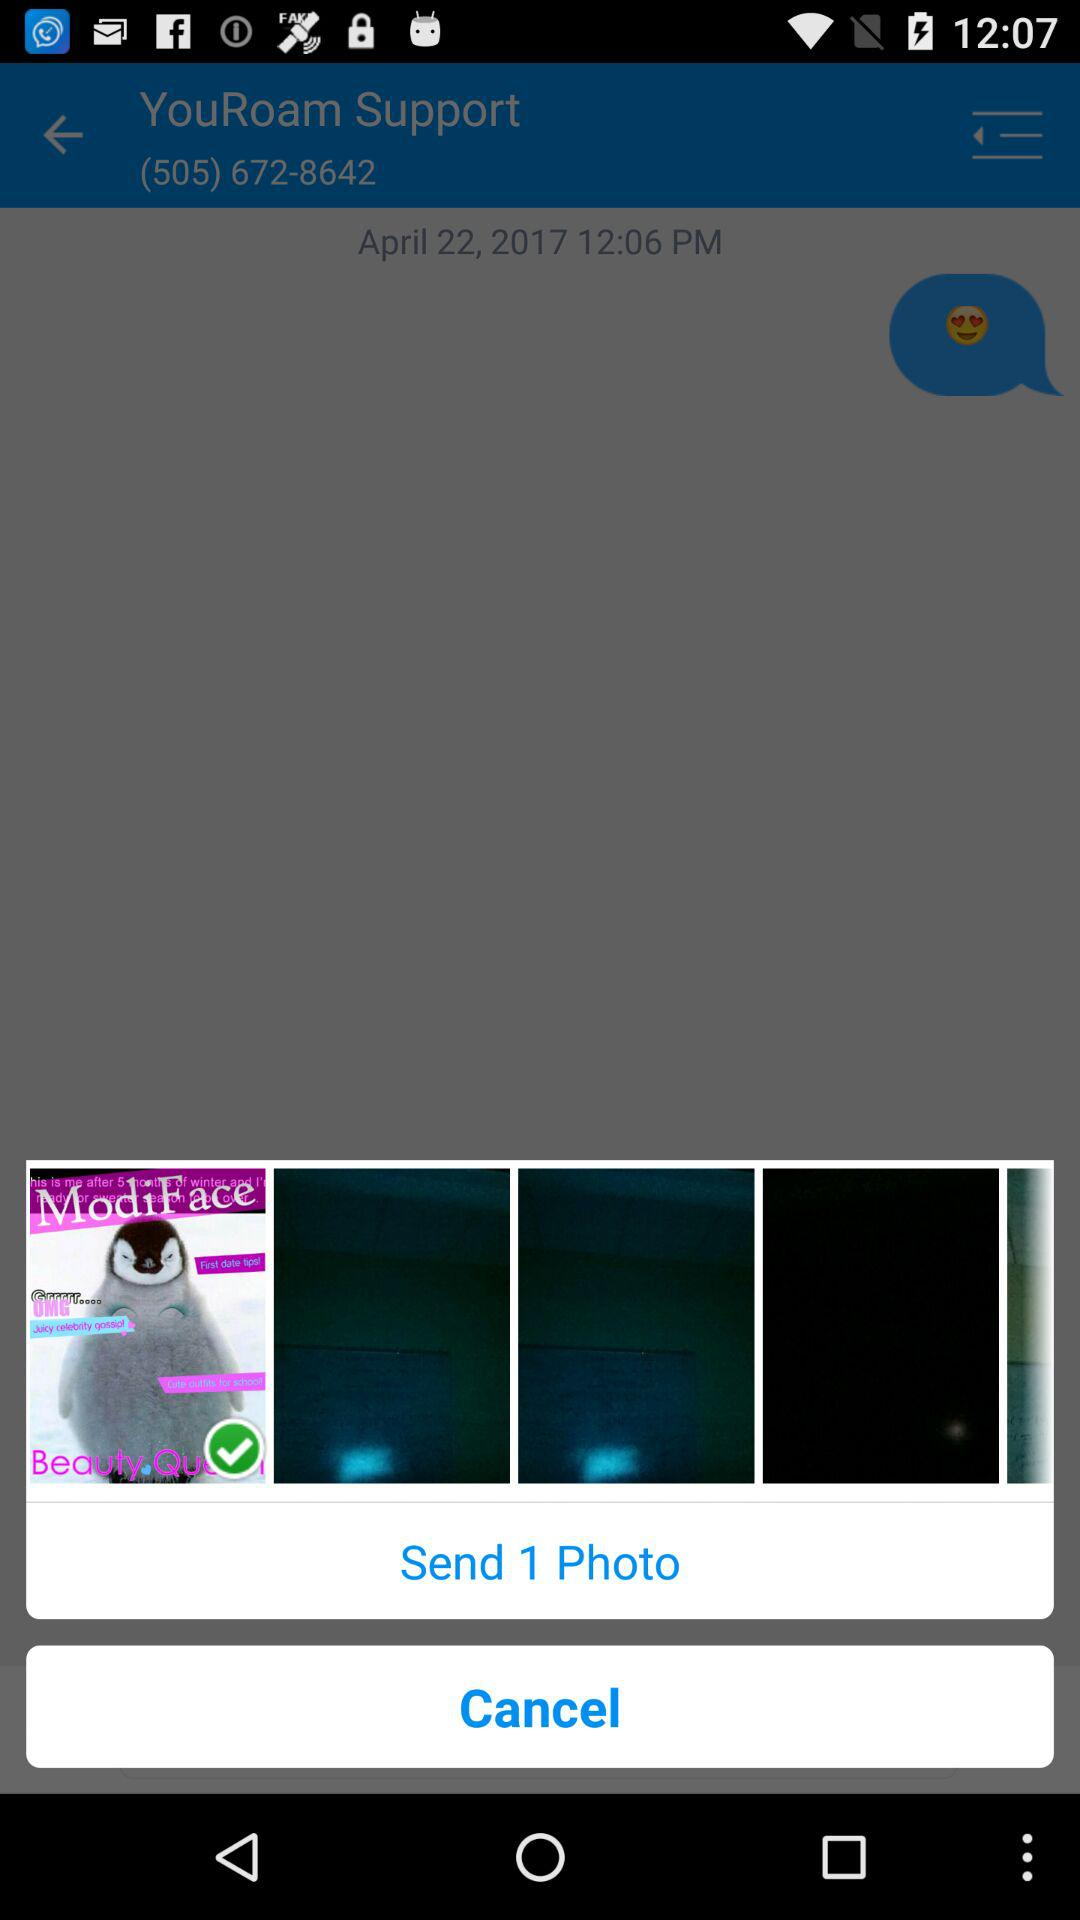How many photos are chosen to be sent? There is 1 photo chosen. 